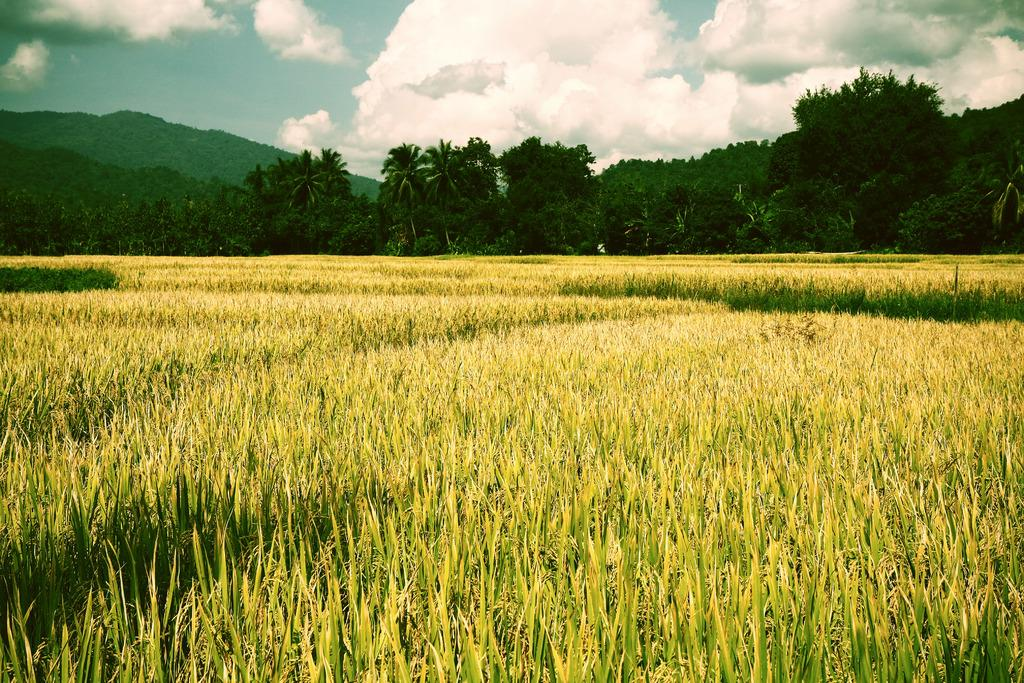What is the main subject of the image? There is a crop in the image. What can be seen behind the crop? There are trees behind the crop. What is visible behind the trees? There are mountains behind the trees. What is visible in the sky at the top of the image? Clouds are visible in the sky at the top of the image. What type of jeans is the plate wearing in the image? There is no plate or jeans present in the image. Can you describe the arm of the person holding the crop in the image? There is no person holding the crop in the image, so it is not possible to describe their arm. 